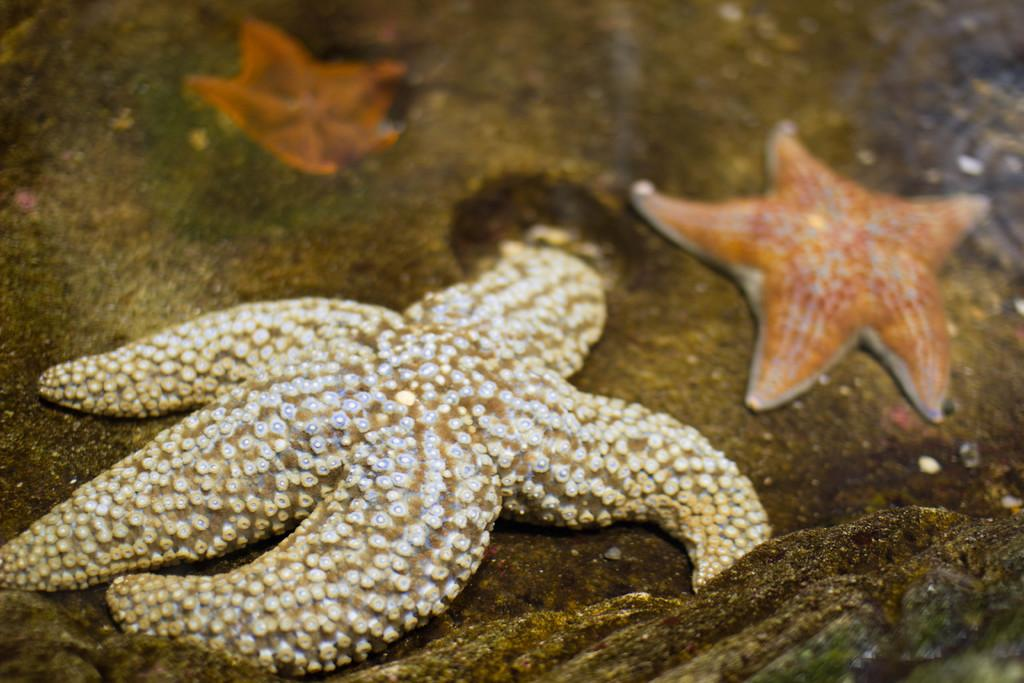What type of marine animal is in the image? There is a starfish in the image. What type of joke is the giraffe telling in the image? There is no giraffe present in the image, and therefore no joke can be observed. What type of berry is the starfish holding in the image? There is no berry present in the image, and the starfish is not holding anything. 